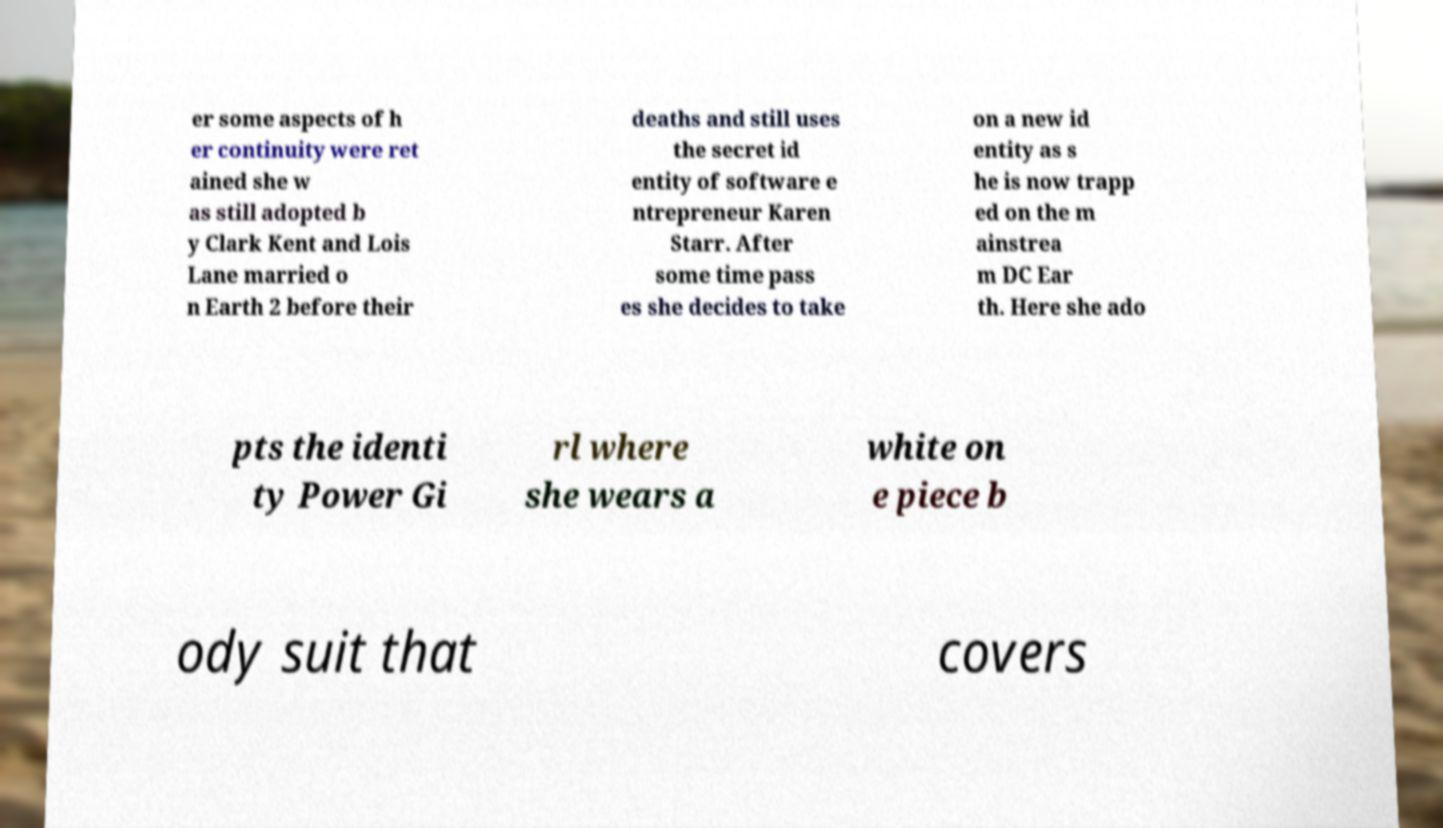Could you extract and type out the text from this image? er some aspects of h er continuity were ret ained she w as still adopted b y Clark Kent and Lois Lane married o n Earth 2 before their deaths and still uses the secret id entity of software e ntrepreneur Karen Starr. After some time pass es she decides to take on a new id entity as s he is now trapp ed on the m ainstrea m DC Ear th. Here she ado pts the identi ty Power Gi rl where she wears a white on e piece b ody suit that covers 